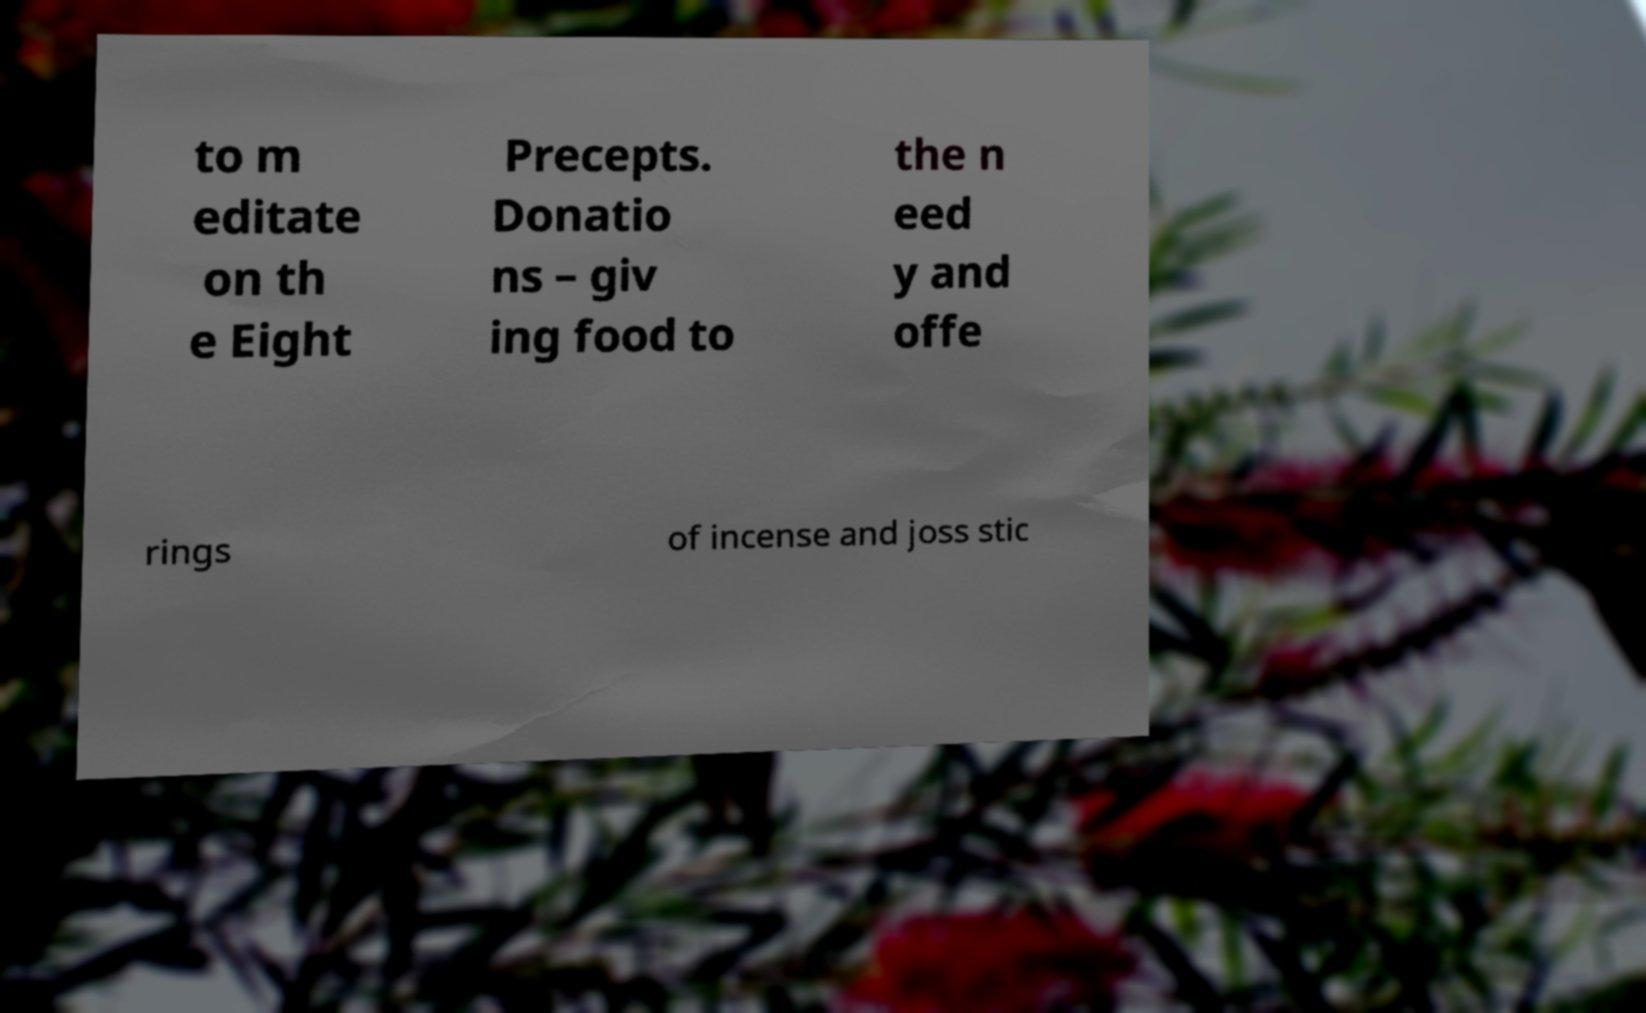There's text embedded in this image that I need extracted. Can you transcribe it verbatim? to m editate on th e Eight Precepts. Donatio ns – giv ing food to the n eed y and offe rings of incense and joss stic 